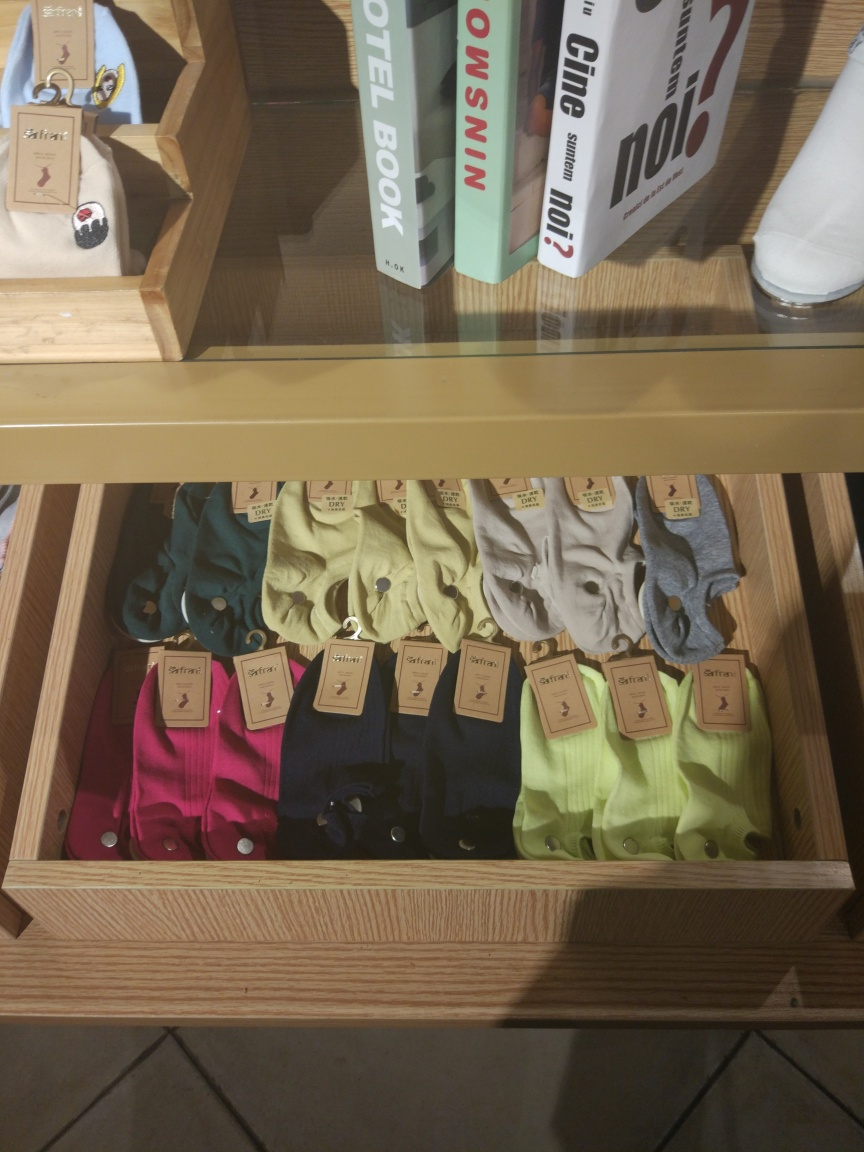Could you tell me more about the types of items and their arrangement in the image? The image shows a selection of polo shirts in a variety of vibrant colors such as pink, green, and blue, all neatly folded and displayed in an open wooden drawer. Each shirt has a visible price tag attached to it, suggesting they are for sale. Above the shirts, there appears to be a selection of books or magazines, hinting that the store might cater to a lifestyle segment, offering a combination of apparel and reading material to its customers. 